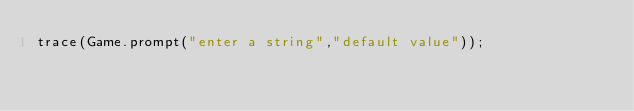<code> <loc_0><loc_0><loc_500><loc_500><_Haxe_>trace(Game.prompt("enter a string","default value"));</code> 